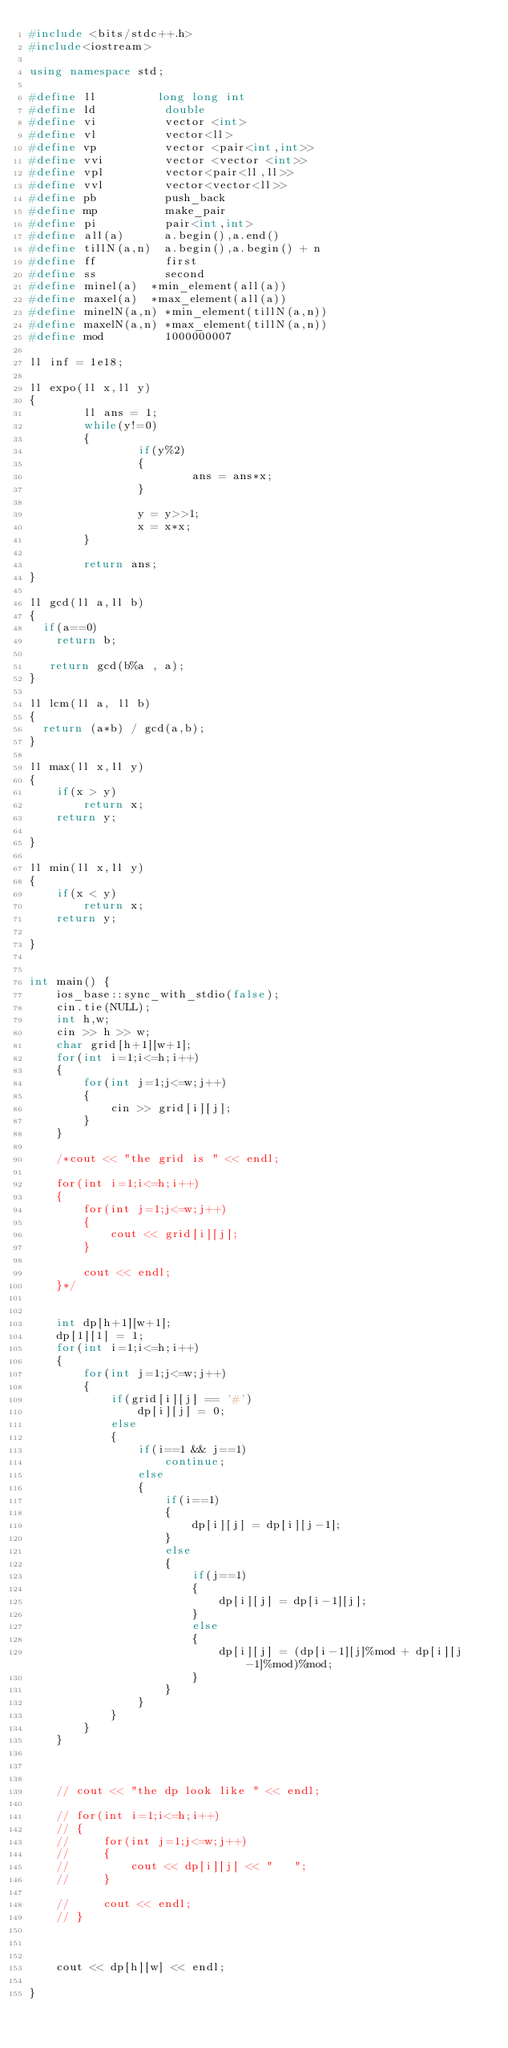<code> <loc_0><loc_0><loc_500><loc_500><_C++_>#include <bits/stdc++.h>
#include<iostream>

using namespace std;

#define ll         long long int
#define ld          double
#define vi          vector <int>
#define vl          vector<ll>
#define vp          vector <pair<int,int>>
#define vvi         vector <vector <int>>
#define vpl         vector<pair<ll,ll>>
#define vvl         vector<vector<ll>>
#define pb          push_back
#define mp          make_pair
#define pi          pair<int,int>
#define all(a)      a.begin(),a.end()
#define tillN(a,n)  a.begin(),a.begin() + n
#define ff          first
#define ss          second
#define minel(a)	*min_element(all(a))
#define maxel(a)	*max_element(all(a))
#define minelN(a,n) *min_element(tillN(a,n))
#define maxelN(a,n) *max_element(tillN(a,n))
#define mod         1000000007

ll inf = 1e18;

ll expo(ll x,ll y)
{
        ll ans = 1;
        while(y!=0)
        {
                if(y%2)
                {
                        ans = ans*x;
                }

                y = y>>1;
                x = x*x;
        }

        return ans;
}

ll gcd(ll a,ll b)
{
	if(a==0)
	  return b;

	 return gcd(b%a , a);
}

ll lcm(ll a, ll b)
{
	return (a*b) / gcd(a,b);
}

ll max(ll x,ll y)
{
    if(x > y)
        return x;
    return y;

}

ll min(ll x,ll y)
{
    if(x < y)
        return x;
    return y;

}

 
int main() {
    ios_base::sync_with_stdio(false);
    cin.tie(NULL);
    int h,w;
    cin >> h >> w;
    char grid[h+1][w+1];
    for(int i=1;i<=h;i++)
    {
        for(int j=1;j<=w;j++)
        {
            cin >> grid[i][j];
        }
    }

    /*cout << "the grid is " << endl;

    for(int i=1;i<=h;i++)
    {
        for(int j=1;j<=w;j++)
        {
            cout << grid[i][j];
        }

        cout << endl;
    }*/


    int dp[h+1][w+1];
    dp[1][1] = 1;
    for(int i=1;i<=h;i++)
    {
        for(int j=1;j<=w;j++)
        {
            if(grid[i][j] == '#')
                dp[i][j] = 0;
            else
            {
                if(i==1 && j==1)
                    continue;
                else
                {
                    if(i==1)
                    {
                        dp[i][j] = dp[i][j-1];
                    }
                    else
                    {
                        if(j==1)
                        {
                            dp[i][j] = dp[i-1][j];
                        }
                        else
                        {
                            dp[i][j] = (dp[i-1][j]%mod + dp[i][j-1]%mod)%mod;
                        }
                    }
                }
            }
        }
    }



    // cout << "the dp look like " << endl;

    // for(int i=1;i<=h;i++)
    // {
    //     for(int j=1;j<=w;j++)
    //     {
    //         cout << dp[i][j] << "   ";
    //     }

    //     cout << endl;
    // }



    cout << dp[h][w] << endl;

}
</code> 